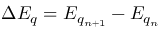<formula> <loc_0><loc_0><loc_500><loc_500>\Delta E _ { q } = E _ { q _ { n + 1 } } - E _ { q _ { n } }</formula> 